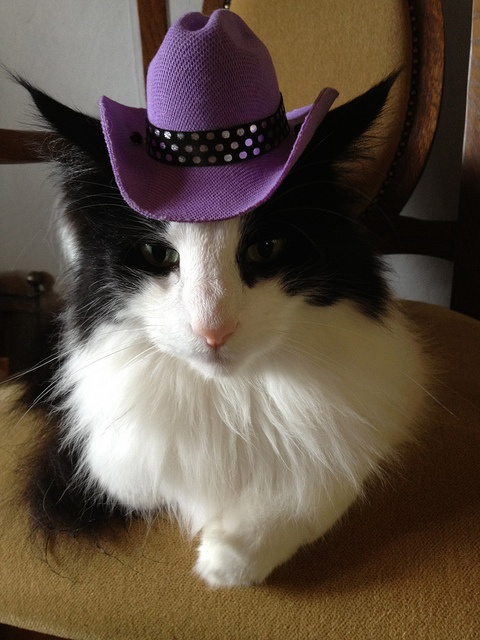Describe the objects in this image and their specific colors. I can see cat in gray, black, darkgray, and lightgray tones and chair in gray, black, olive, and maroon tones in this image. 